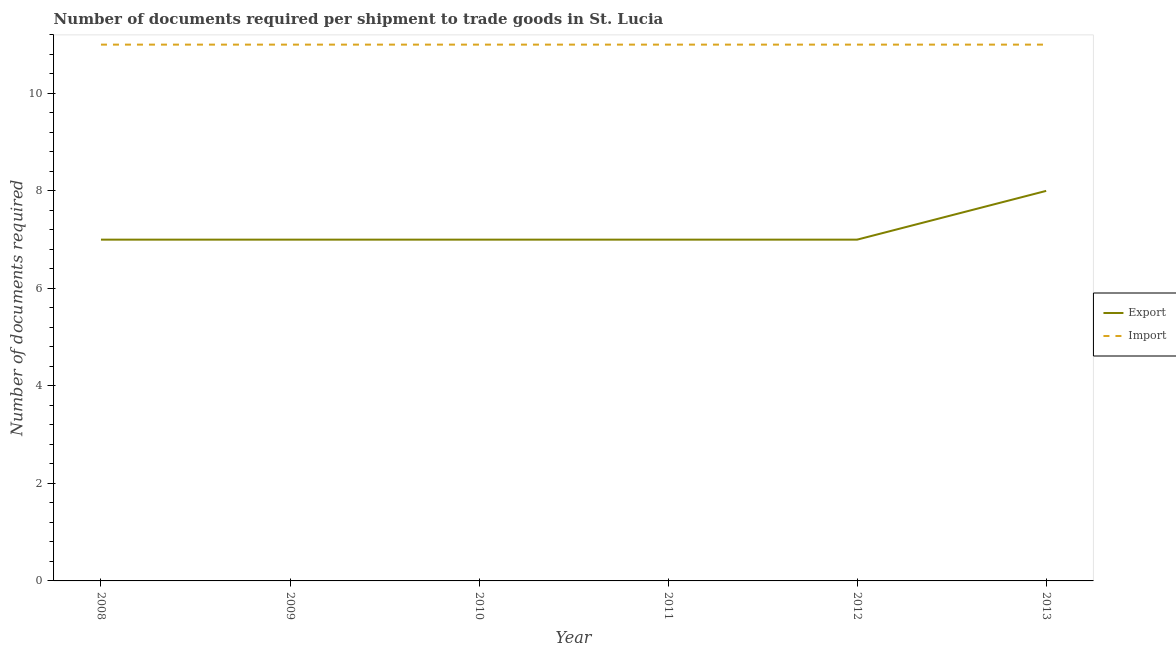How many different coloured lines are there?
Provide a succinct answer. 2. What is the number of documents required to export goods in 2012?
Provide a succinct answer. 7. Across all years, what is the maximum number of documents required to import goods?
Provide a succinct answer. 11. Across all years, what is the minimum number of documents required to export goods?
Your response must be concise. 7. What is the total number of documents required to import goods in the graph?
Provide a short and direct response. 66. What is the difference between the number of documents required to import goods in 2009 and that in 2012?
Give a very brief answer. 0. What is the difference between the number of documents required to import goods in 2011 and the number of documents required to export goods in 2008?
Ensure brevity in your answer.  4. What is the average number of documents required to export goods per year?
Offer a terse response. 7.17. In the year 2013, what is the difference between the number of documents required to export goods and number of documents required to import goods?
Your response must be concise. -3. Is the number of documents required to export goods in 2010 less than that in 2011?
Provide a short and direct response. No. What is the difference between the highest and the second highest number of documents required to export goods?
Keep it short and to the point. 1. What is the difference between the highest and the lowest number of documents required to export goods?
Offer a very short reply. 1. In how many years, is the number of documents required to import goods greater than the average number of documents required to import goods taken over all years?
Make the answer very short. 0. Is the sum of the number of documents required to export goods in 2009 and 2011 greater than the maximum number of documents required to import goods across all years?
Keep it short and to the point. Yes. Is the number of documents required to import goods strictly greater than the number of documents required to export goods over the years?
Offer a terse response. Yes. Is the number of documents required to import goods strictly less than the number of documents required to export goods over the years?
Your response must be concise. No. How many lines are there?
Give a very brief answer. 2. How many years are there in the graph?
Provide a short and direct response. 6. What is the difference between two consecutive major ticks on the Y-axis?
Give a very brief answer. 2. Does the graph contain any zero values?
Offer a terse response. No. What is the title of the graph?
Provide a short and direct response. Number of documents required per shipment to trade goods in St. Lucia. What is the label or title of the X-axis?
Your answer should be very brief. Year. What is the label or title of the Y-axis?
Offer a terse response. Number of documents required. What is the Number of documents required of Export in 2009?
Make the answer very short. 7. What is the Number of documents required in Import in 2009?
Provide a short and direct response. 11. What is the Number of documents required of Import in 2010?
Ensure brevity in your answer.  11. What is the Number of documents required of Import in 2011?
Your answer should be compact. 11. What is the Number of documents required in Export in 2013?
Make the answer very short. 8. What is the Number of documents required in Import in 2013?
Keep it short and to the point. 11. Across all years, what is the maximum Number of documents required of Import?
Make the answer very short. 11. Across all years, what is the minimum Number of documents required in Import?
Your response must be concise. 11. What is the difference between the Number of documents required in Export in 2008 and that in 2009?
Provide a succinct answer. 0. What is the difference between the Number of documents required of Export in 2008 and that in 2010?
Your answer should be very brief. 0. What is the difference between the Number of documents required of Export in 2008 and that in 2012?
Offer a terse response. 0. What is the difference between the Number of documents required in Export in 2008 and that in 2013?
Ensure brevity in your answer.  -1. What is the difference between the Number of documents required of Import in 2008 and that in 2013?
Give a very brief answer. 0. What is the difference between the Number of documents required of Export in 2009 and that in 2010?
Provide a succinct answer. 0. What is the difference between the Number of documents required of Export in 2009 and that in 2012?
Your answer should be compact. 0. What is the difference between the Number of documents required in Export in 2009 and that in 2013?
Give a very brief answer. -1. What is the difference between the Number of documents required in Export in 2010 and that in 2012?
Provide a short and direct response. 0. What is the difference between the Number of documents required of Import in 2010 and that in 2013?
Ensure brevity in your answer.  0. What is the difference between the Number of documents required in Import in 2011 and that in 2012?
Offer a very short reply. 0. What is the difference between the Number of documents required in Import in 2011 and that in 2013?
Provide a succinct answer. 0. What is the difference between the Number of documents required of Export in 2012 and that in 2013?
Your answer should be very brief. -1. What is the difference between the Number of documents required of Import in 2012 and that in 2013?
Keep it short and to the point. 0. What is the difference between the Number of documents required in Export in 2008 and the Number of documents required in Import in 2009?
Your response must be concise. -4. What is the difference between the Number of documents required of Export in 2008 and the Number of documents required of Import in 2010?
Offer a terse response. -4. What is the difference between the Number of documents required in Export in 2008 and the Number of documents required in Import in 2011?
Provide a short and direct response. -4. What is the difference between the Number of documents required in Export in 2008 and the Number of documents required in Import in 2012?
Your answer should be very brief. -4. What is the difference between the Number of documents required of Export in 2008 and the Number of documents required of Import in 2013?
Provide a short and direct response. -4. What is the difference between the Number of documents required in Export in 2009 and the Number of documents required in Import in 2011?
Your answer should be compact. -4. What is the difference between the Number of documents required of Export in 2010 and the Number of documents required of Import in 2011?
Provide a short and direct response. -4. What is the difference between the Number of documents required of Export in 2010 and the Number of documents required of Import in 2012?
Ensure brevity in your answer.  -4. What is the average Number of documents required of Export per year?
Provide a short and direct response. 7.17. What is the average Number of documents required in Import per year?
Provide a succinct answer. 11. In the year 2008, what is the difference between the Number of documents required in Export and Number of documents required in Import?
Offer a very short reply. -4. In the year 2009, what is the difference between the Number of documents required of Export and Number of documents required of Import?
Ensure brevity in your answer.  -4. In the year 2011, what is the difference between the Number of documents required in Export and Number of documents required in Import?
Provide a short and direct response. -4. In the year 2012, what is the difference between the Number of documents required in Export and Number of documents required in Import?
Provide a succinct answer. -4. In the year 2013, what is the difference between the Number of documents required in Export and Number of documents required in Import?
Your answer should be compact. -3. What is the ratio of the Number of documents required in Export in 2008 to that in 2010?
Offer a terse response. 1. What is the ratio of the Number of documents required in Import in 2009 to that in 2010?
Your answer should be compact. 1. What is the ratio of the Number of documents required of Export in 2009 to that in 2011?
Give a very brief answer. 1. What is the ratio of the Number of documents required of Export in 2009 to that in 2013?
Your answer should be compact. 0.88. What is the ratio of the Number of documents required in Import in 2009 to that in 2013?
Offer a terse response. 1. What is the ratio of the Number of documents required in Import in 2010 to that in 2011?
Offer a very short reply. 1. What is the ratio of the Number of documents required in Export in 2010 to that in 2013?
Ensure brevity in your answer.  0.88. What is the ratio of the Number of documents required of Export in 2011 to that in 2012?
Offer a very short reply. 1. What is the ratio of the Number of documents required in Import in 2011 to that in 2012?
Keep it short and to the point. 1. What is the ratio of the Number of documents required in Export in 2011 to that in 2013?
Make the answer very short. 0.88. What is the difference between the highest and the second highest Number of documents required of Export?
Give a very brief answer. 1. What is the difference between the highest and the second highest Number of documents required in Import?
Your answer should be very brief. 0. What is the difference between the highest and the lowest Number of documents required in Import?
Offer a terse response. 0. 